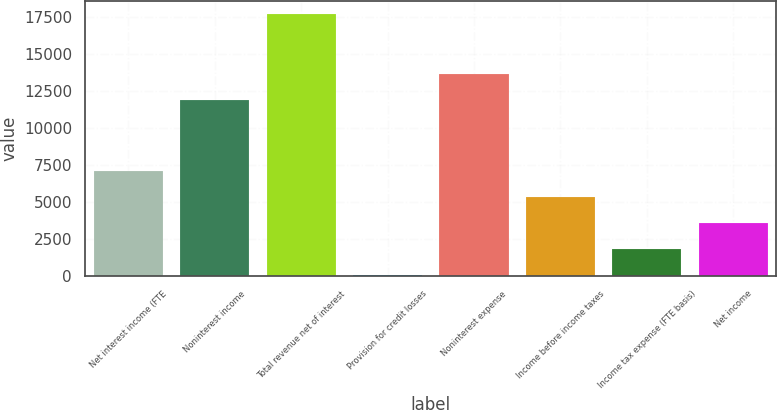Convert chart. <chart><loc_0><loc_0><loc_500><loc_500><bar_chart><fcel>Net interest income (FTE<fcel>Noninterest income<fcel>Total revenue net of interest<fcel>Provision for credit losses<fcel>Noninterest expense<fcel>Income before income taxes<fcel>Income tax expense (FTE basis)<fcel>Net income<nl><fcel>7100.8<fcel>11891<fcel>17650<fcel>68<fcel>13649.2<fcel>5342.6<fcel>1826.2<fcel>3584.4<nl></chart> 